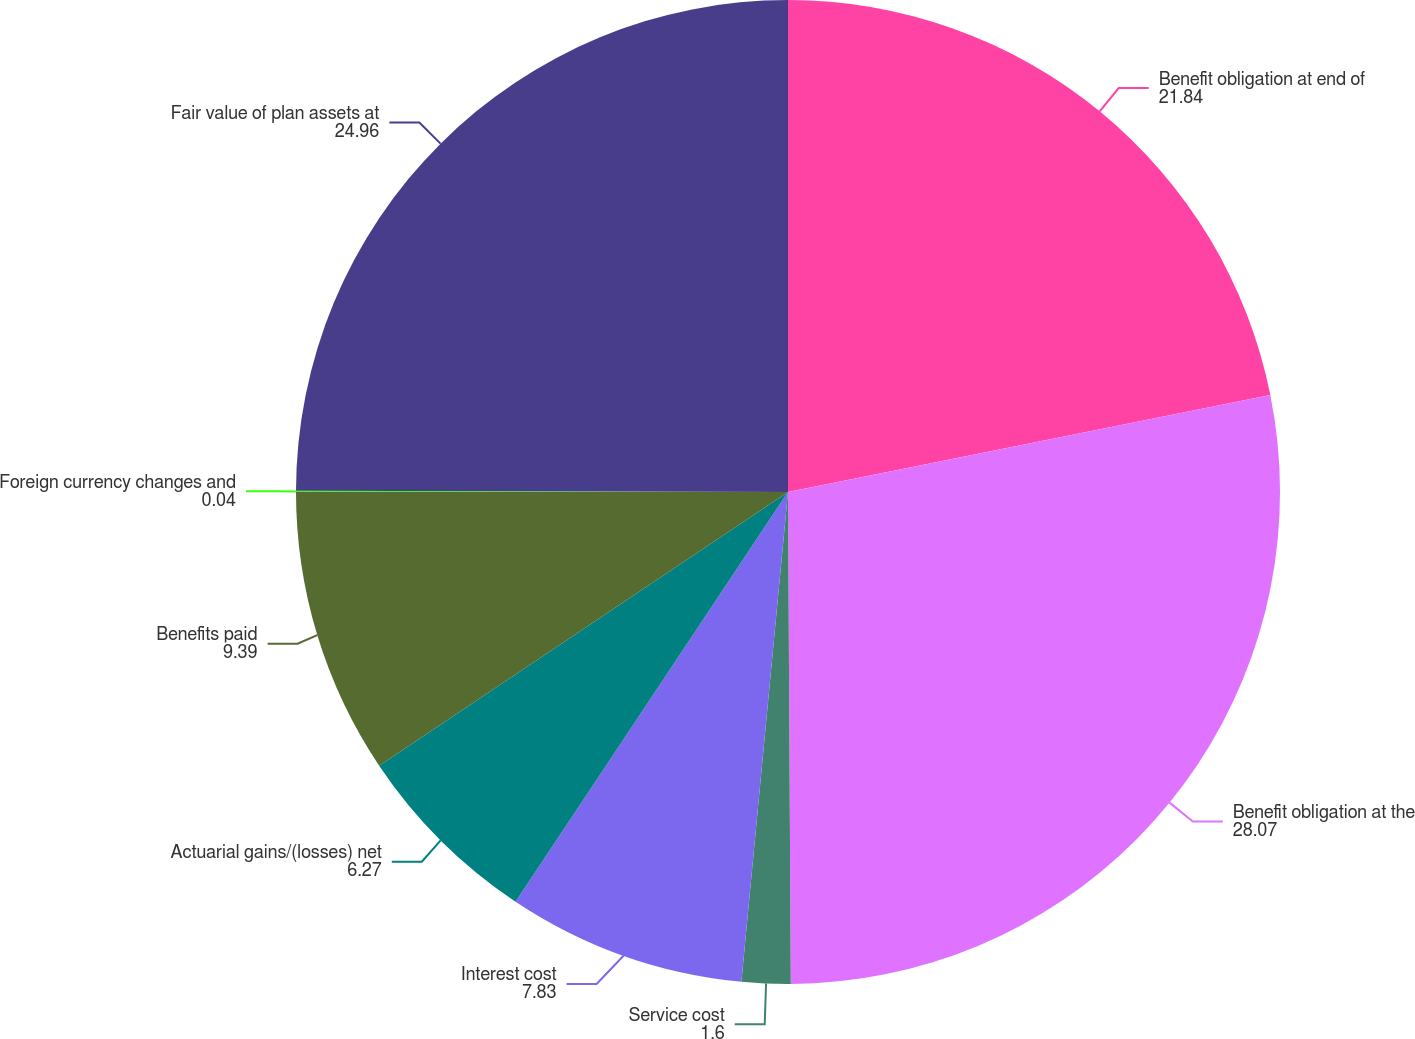Convert chart. <chart><loc_0><loc_0><loc_500><loc_500><pie_chart><fcel>Benefit obligation at end of<fcel>Benefit obligation at the<fcel>Service cost<fcel>Interest cost<fcel>Actuarial gains/(losses) net<fcel>Benefits paid<fcel>Foreign currency changes and<fcel>Fair value of plan assets at<nl><fcel>21.84%<fcel>28.07%<fcel>1.6%<fcel>7.83%<fcel>6.27%<fcel>9.39%<fcel>0.04%<fcel>24.96%<nl></chart> 